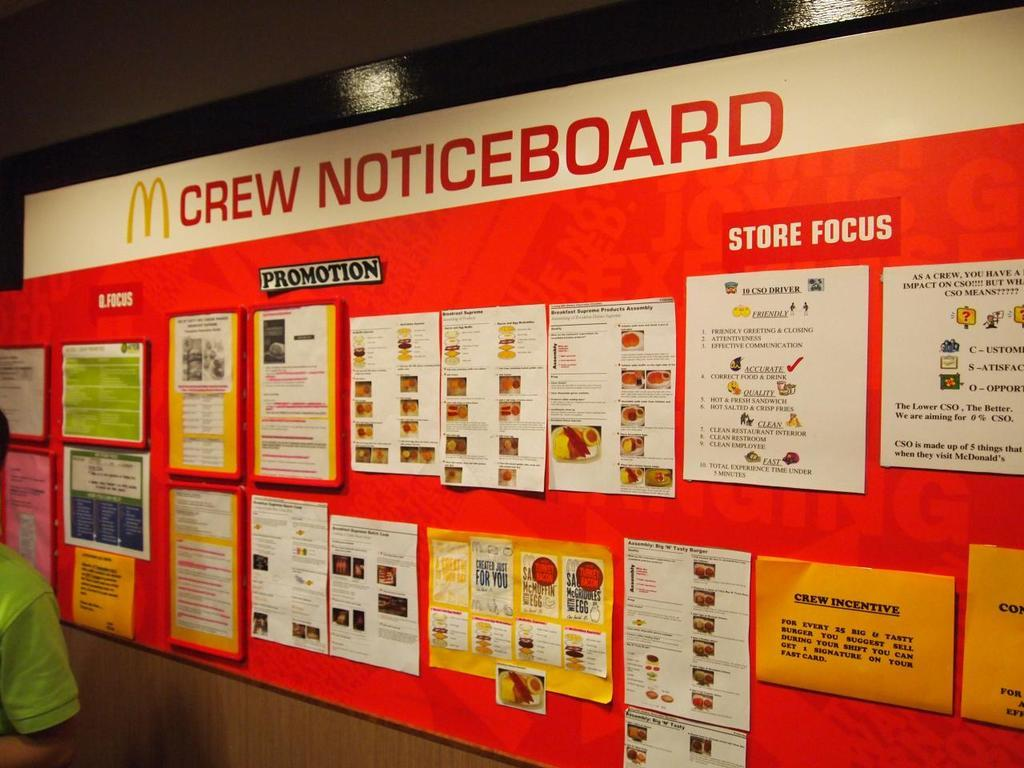Provide a one-sentence caption for the provided image. A red board called the M Crew Noticeboard. 